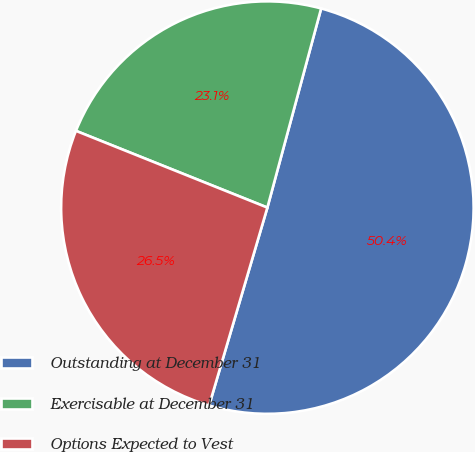Convert chart. <chart><loc_0><loc_0><loc_500><loc_500><pie_chart><fcel>Outstanding at December 31<fcel>Exercisable at December 31<fcel>Options Expected to Vest<nl><fcel>50.36%<fcel>23.13%<fcel>26.51%<nl></chart> 